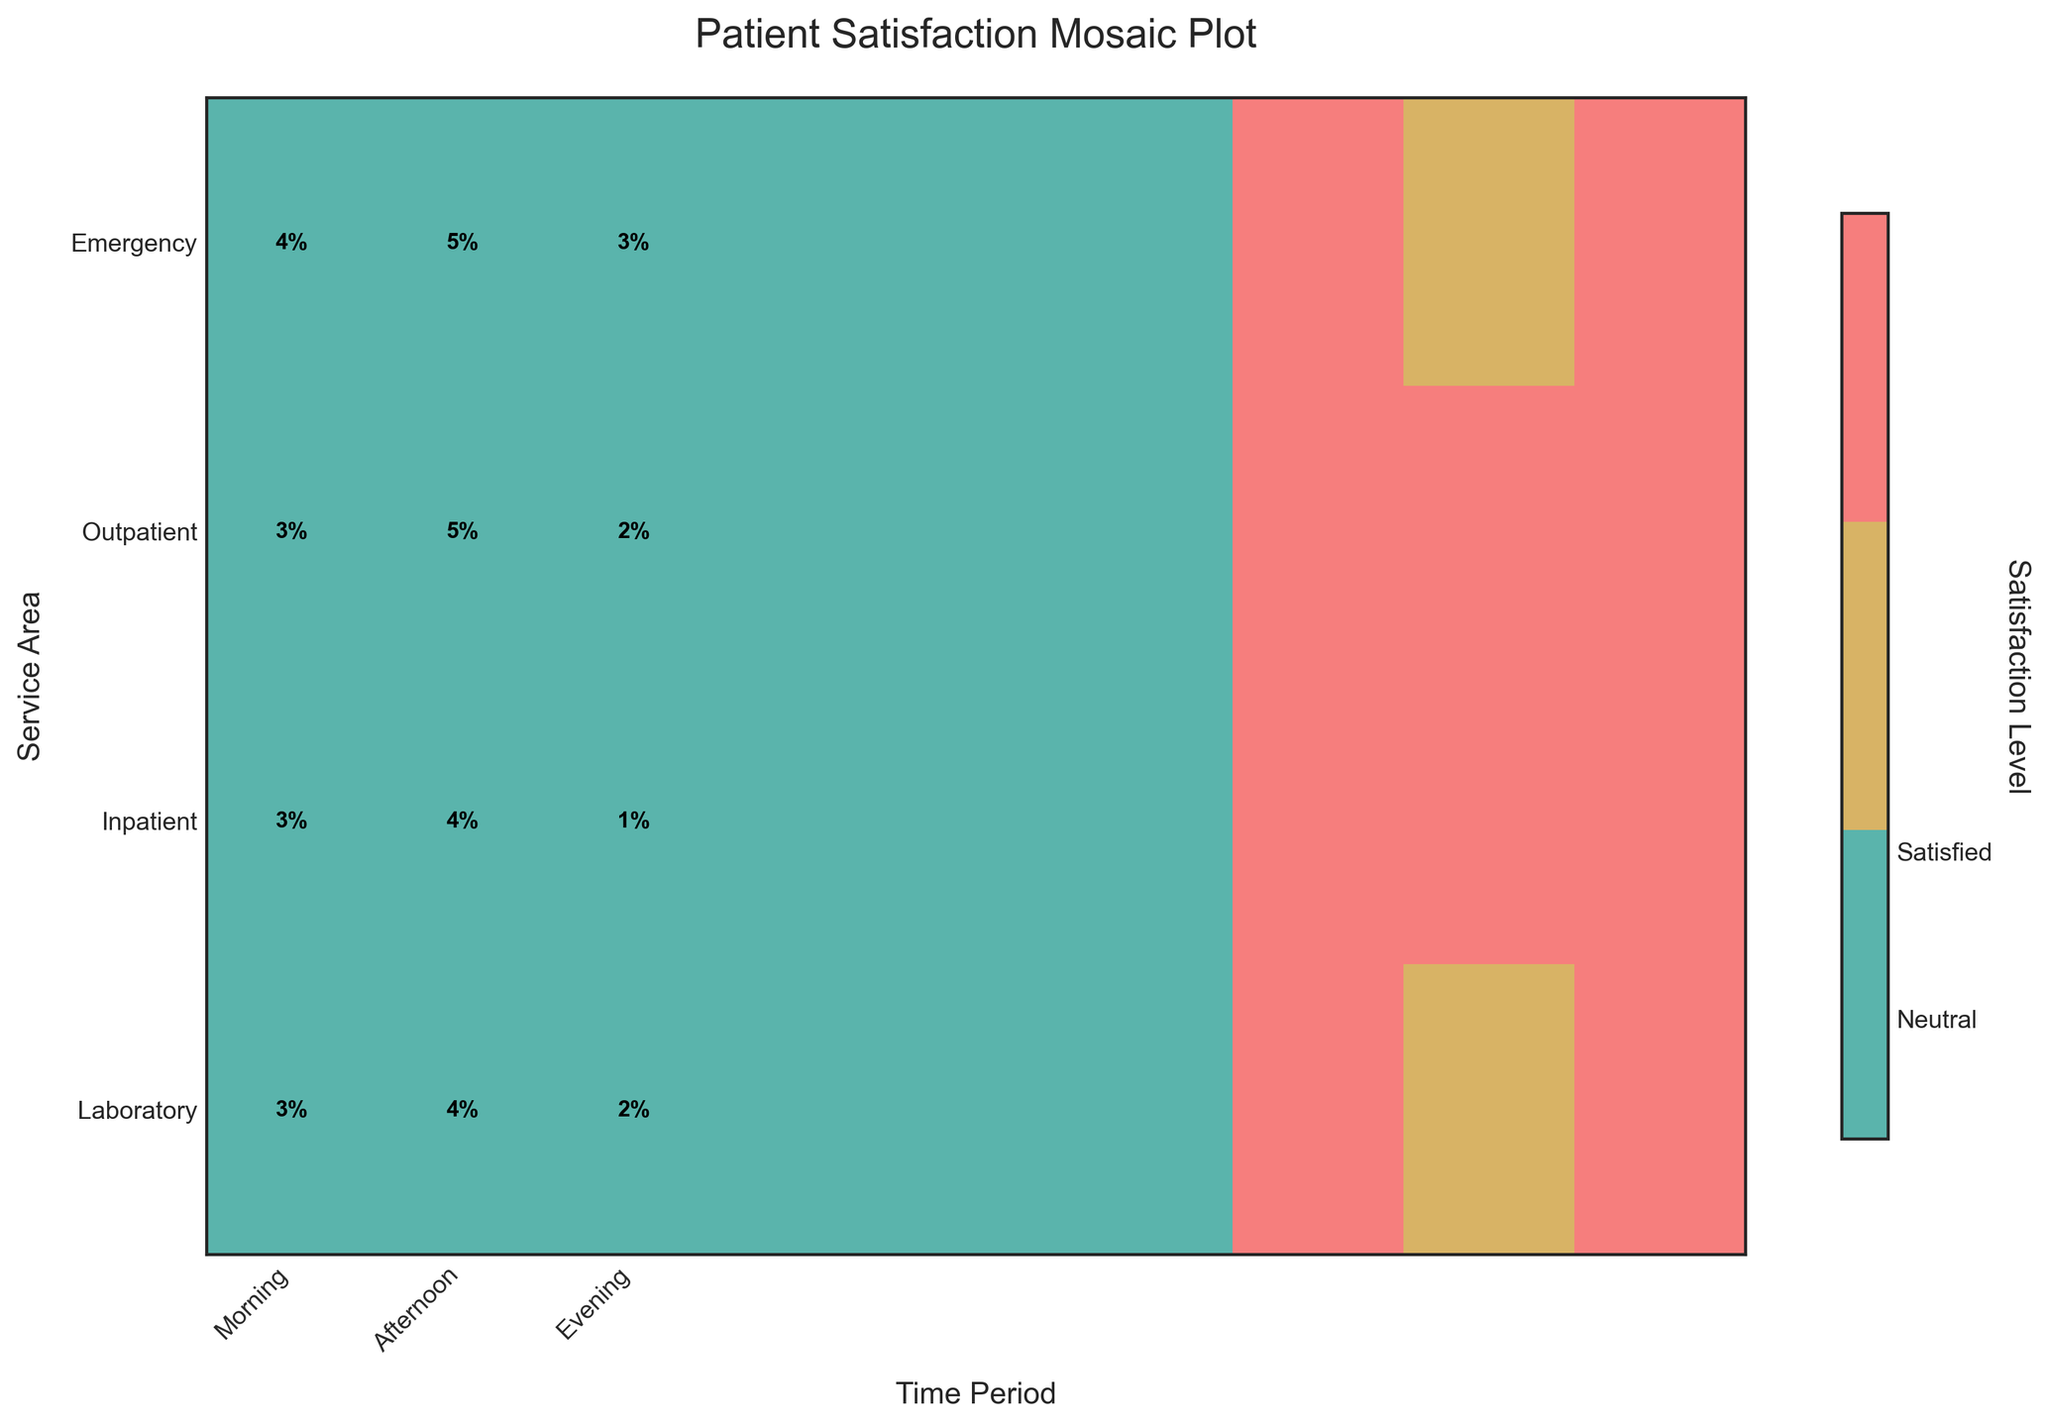What's the title of the plot? The title of the plot is typically situated at the top center of the figure. It provides an overview of what the plot is about, which in this case, is "Patient Satisfaction Mosaic Plot".
Answer: Patient Satisfaction Mosaic Plot Which service area has the highest satisfaction percentage in the morning? Check the morning time period column and identify the highest value in the 'Satisfied' section for each service area row. The 'Outpatient' row has the highest percentage in the morning.
Answer: Outpatient Comparing the afternoon time period, which service area had more neutral patients: Emergency or Laboratory? Look at the neutral section for both the 'Emergency' and 'Laboratory' rows in the afternoon column. The 'Laboratory' has a higher percentage of neutral patients than 'Emergency'.
Answer: Laboratory Which time period had the least dissatisfaction for Inpatient services? Check the 'Dissatisfied' sections for the 'Inpatient' row across all time periods, and identify the lowest percentage. The morning time period has the least dissatisfaction.
Answer: Morning Are there any service areas where dissatisfaction is higher in the evening compared to the morning? Compare the 'Dissatisfied' sections in the evening and morning columns for each service area. 'Emergency', 'Inpatient', and 'Laboratory' show higher dissatisfaction in the evening compared to the morning.
Answer: Yes, Emergency, Inpatient, and Laboratory What is the trend in satisfaction levels for Outpatient services across different time periods? Examine the 'Satisfied' sections for the 'Outpatient' row across morning, afternoon, and evening columns. The satisfaction percentage decreases from morning to evening.
Answer: Decreasing Which service area has a relatively balanced distribution across all three satisfaction levels in the afternoon? Look at the afternoon column for each service area and observe the balance between 'Satisfied', 'Neutral', and 'Dissatisfied'. 'Laboratory' shows a more balanced distribution compared to other service areas.
Answer: Laboratory How does Emergency service satisfaction in the evening compare to the morning? Compare the 'Satisfied' sections for the 'Emergency' row between morning and evening columns. Satisfaction is higher in the morning than in the evening.
Answer: Higher in the morning 